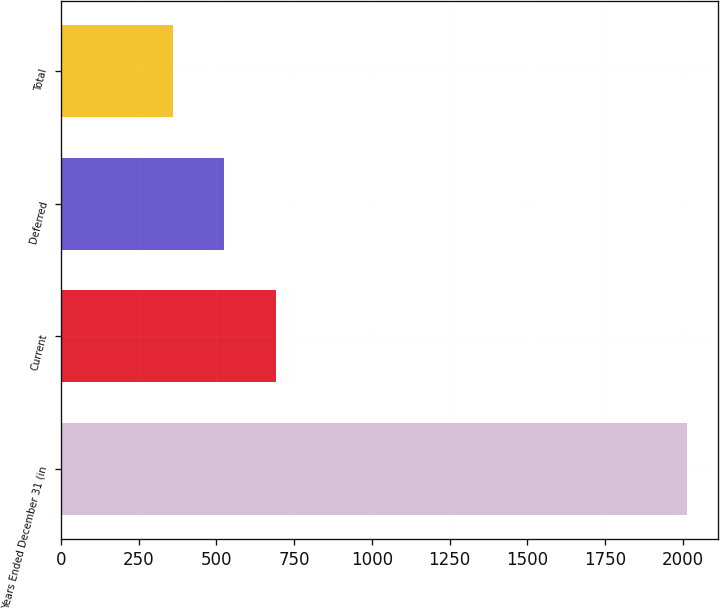<chart> <loc_0><loc_0><loc_500><loc_500><bar_chart><fcel>Years Ended December 31 (in<fcel>Current<fcel>Deferred<fcel>Total<nl><fcel>2013<fcel>690.6<fcel>525.3<fcel>360<nl></chart> 